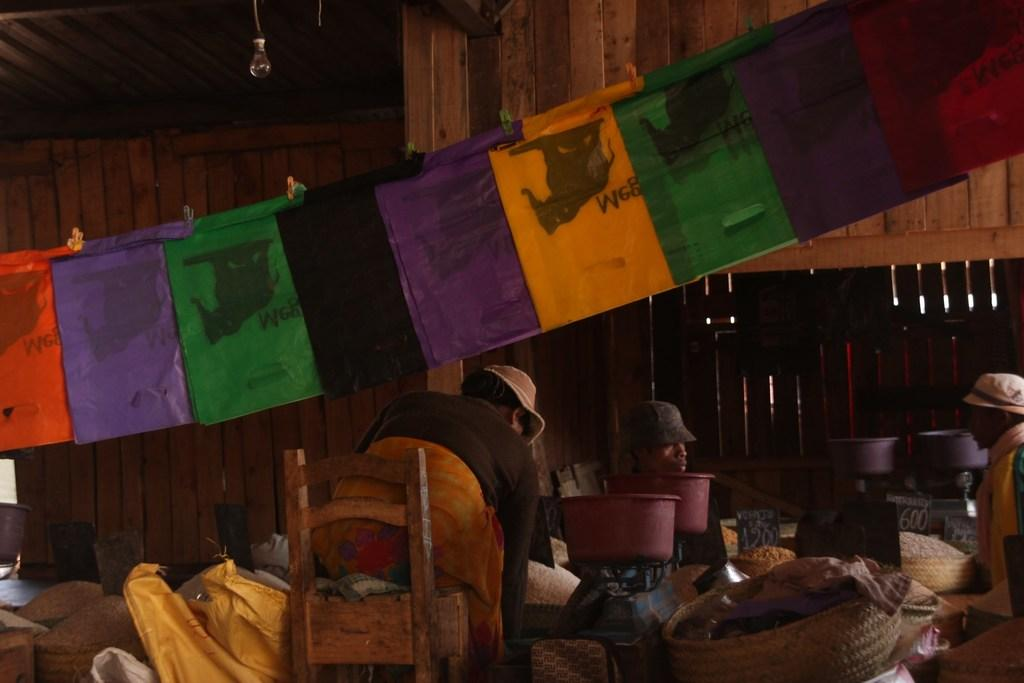How many people are in the image? There are three persons in the image. What are the people wearing on their heads? Each person is wearing a cap. What objects can be seen in the image besides the people? There is a basket, a tub, and a chair in the image. What else is present in the image? Clothes are present in the image. What can be seen at the top of the image? There is a light visible at the top of the image. How many houses can be seen in the image? There are no houses visible in the image. Is there an umbrella being used by any of the persons in the image? There is no umbrella present in the image. 